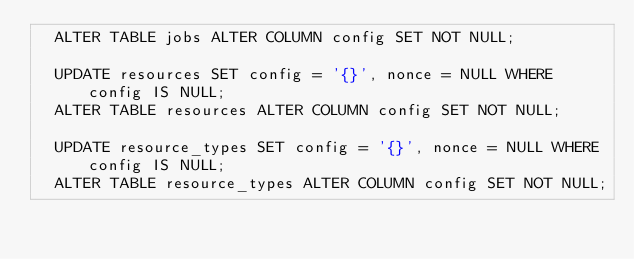Convert code to text. <code><loc_0><loc_0><loc_500><loc_500><_SQL_>  ALTER TABLE jobs ALTER COLUMN config SET NOT NULL;

  UPDATE resources SET config = '{}', nonce = NULL WHERE config IS NULL;
  ALTER TABLE resources ALTER COLUMN config SET NOT NULL;

  UPDATE resource_types SET config = '{}', nonce = NULL WHERE config IS NULL;
  ALTER TABLE resource_types ALTER COLUMN config SET NOT NULL;
</code> 